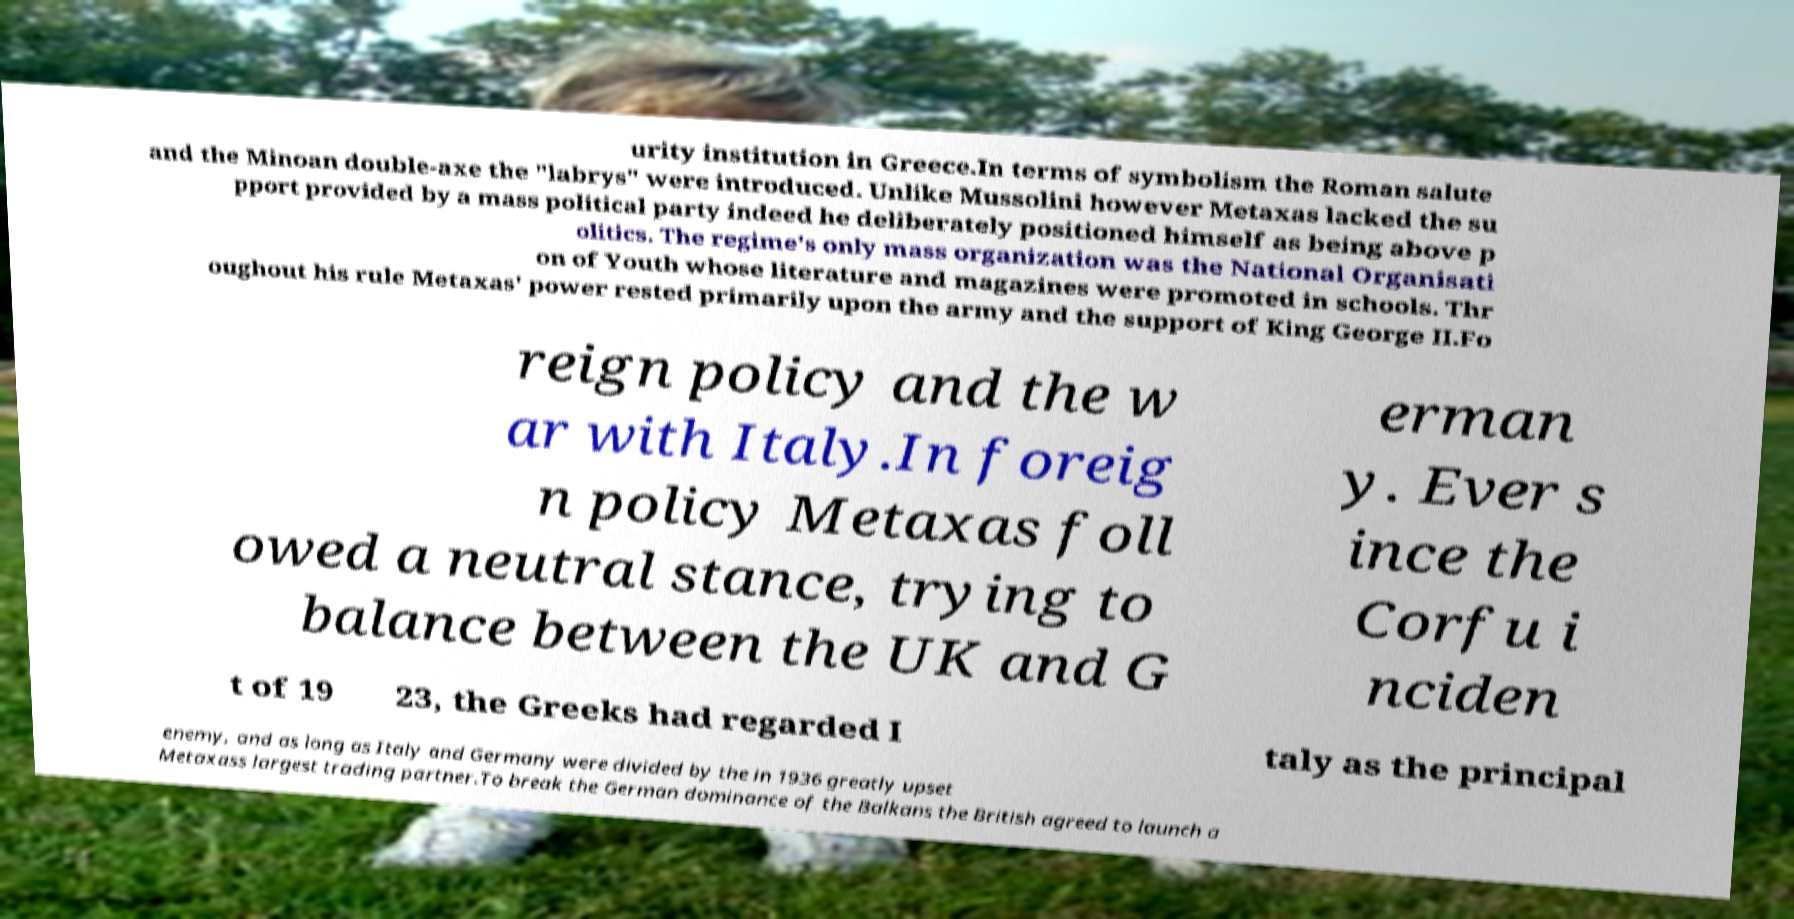For documentation purposes, I need the text within this image transcribed. Could you provide that? urity institution in Greece.In terms of symbolism the Roman salute and the Minoan double-axe the "labrys" were introduced. Unlike Mussolini however Metaxas lacked the su pport provided by a mass political party indeed he deliberately positioned himself as being above p olitics. The regime's only mass organization was the National Organisati on of Youth whose literature and magazines were promoted in schools. Thr oughout his rule Metaxas' power rested primarily upon the army and the support of King George II.Fo reign policy and the w ar with Italy.In foreig n policy Metaxas foll owed a neutral stance, trying to balance between the UK and G erman y. Ever s ince the Corfu i nciden t of 19 23, the Greeks had regarded I taly as the principal enemy, and as long as Italy and Germany were divided by the in 1936 greatly upset Metaxass largest trading partner.To break the German dominance of the Balkans the British agreed to launch a 